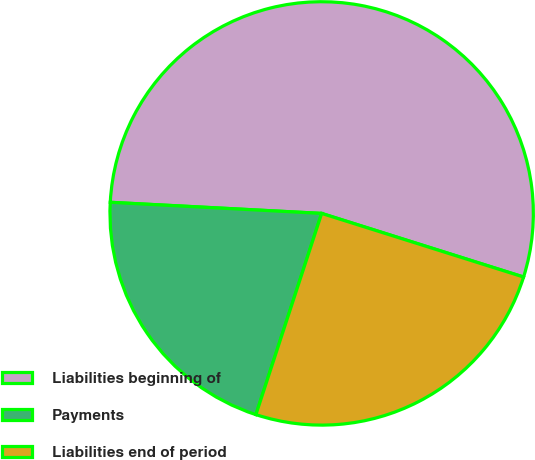Convert chart to OTSL. <chart><loc_0><loc_0><loc_500><loc_500><pie_chart><fcel>Liabilities beginning of<fcel>Payments<fcel>Liabilities end of period<nl><fcel>54.02%<fcel>20.81%<fcel>25.17%<nl></chart> 